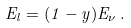<formula> <loc_0><loc_0><loc_500><loc_500>E _ { l } = ( 1 - y ) E _ { \nu } \, .</formula> 